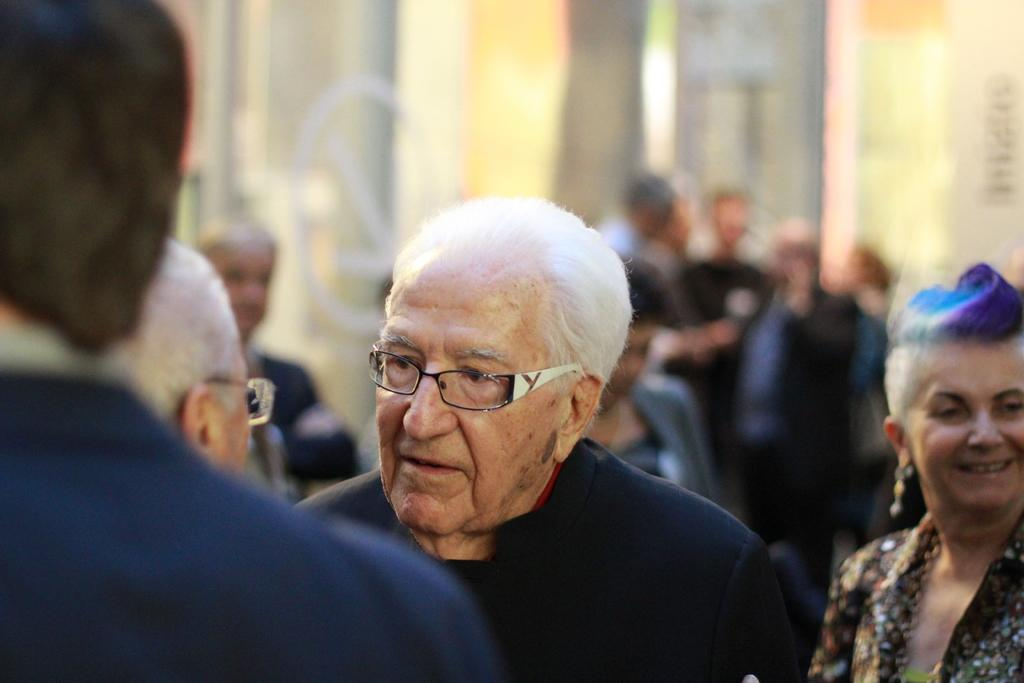What is the main subject of the image? The main subject of the image is an old man standing. What can be observed about the old man's appearance? The old man is wearing specs. Are there any other people visible in the image? Yes, there are people standing in the background of the image. What is the old man's interest in railway systems in the image? There is no indication in the image of the old man's interest in railway systems. 